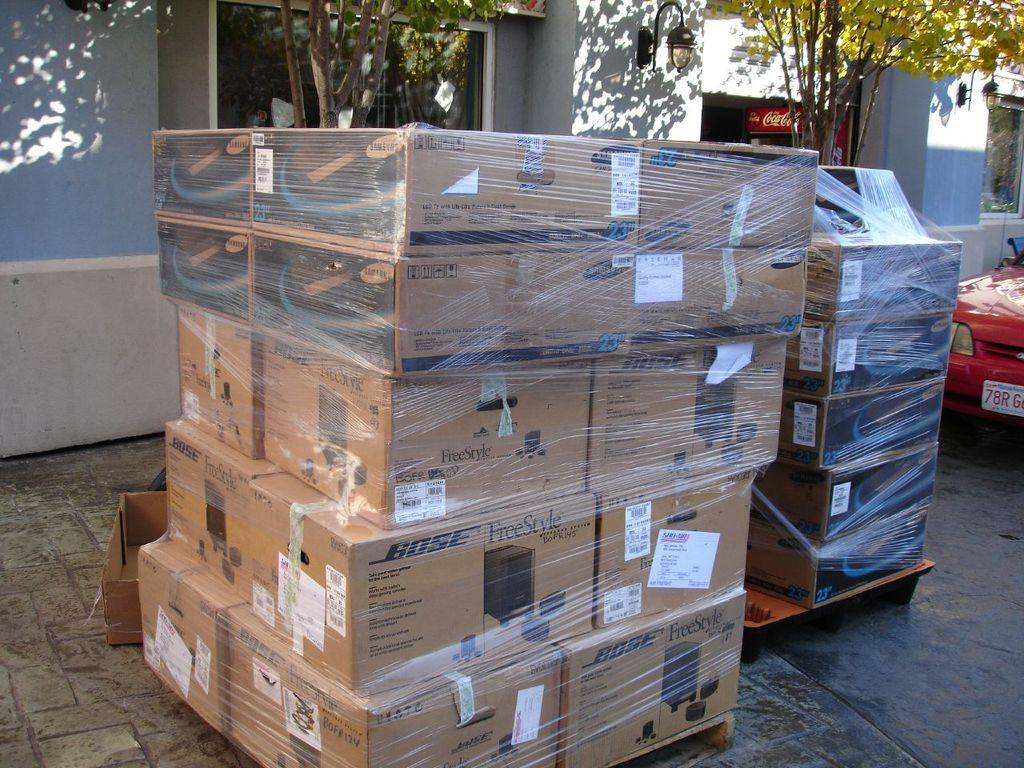<image>
Create a compact narrative representing the image presented. Many boxes with the word Bose on it 